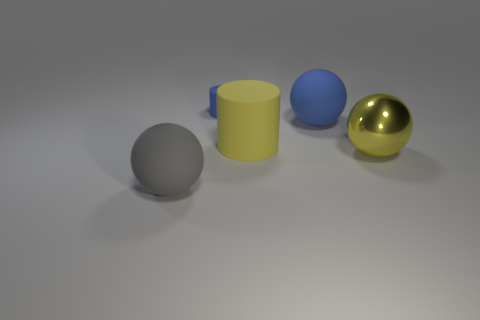Add 1 blue rubber cylinders. How many objects exist? 6 Subtract all spheres. How many objects are left? 2 Add 2 shiny objects. How many shiny objects are left? 3 Add 1 small blue things. How many small blue things exist? 2 Subtract 0 cyan spheres. How many objects are left? 5 Subtract all metal things. Subtract all blue things. How many objects are left? 2 